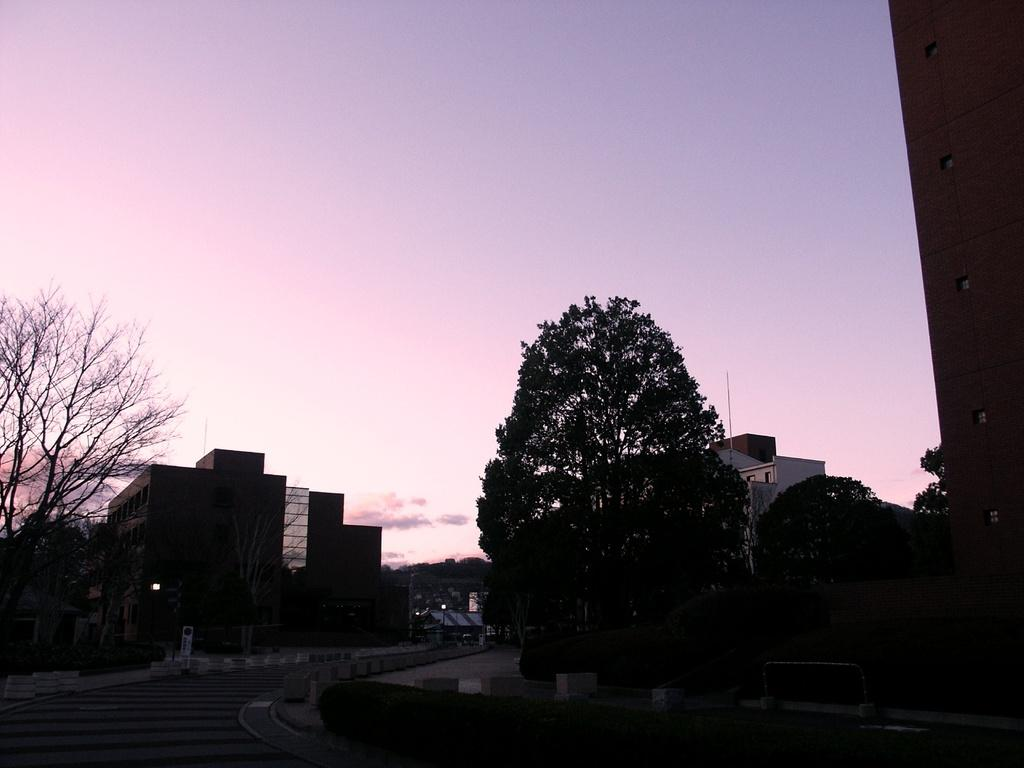What type of natural elements can be seen in the image? There are trees in the image. What type of man-made structures are present in the image? There are buildings in the image. What type of transportation infrastructure is visible in the image? There is a road in the image. What type of water feature can be seen in the image? There is water visible in the image. What type of illumination is present in the image? There are lights in the image. What part of the natural environment is visible in the image? The sky is visible in the image. Where is the print of the nest located in the image? There is no print or nest present in the image. How many cows can be seen grazing in the image? There are no cows present in the image. 